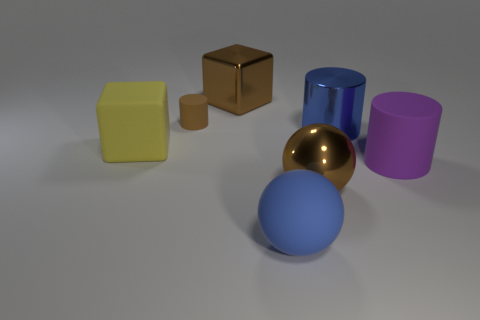Are there any other things that have the same size as the brown matte cylinder?
Offer a terse response. No. There is a brown object that is the same shape as the big yellow object; what is it made of?
Your answer should be very brief. Metal. Is there a big gray cylinder?
Offer a terse response. No. There is a object that is both left of the large blue matte thing and in front of the big blue metal thing; how big is it?
Your answer should be compact. Large. The purple matte object is what shape?
Your response must be concise. Cylinder. Are there any matte cubes to the right of the large block to the right of the tiny matte thing?
Make the answer very short. No. What is the material of the purple cylinder that is the same size as the yellow cube?
Your answer should be very brief. Rubber. Is there a purple metal sphere that has the same size as the brown shiny cube?
Give a very brief answer. No. There is a big cylinder behind the large purple matte cylinder; what is it made of?
Offer a terse response. Metal. Is the large brown object behind the yellow rubber cube made of the same material as the tiny cylinder?
Provide a short and direct response. No. 